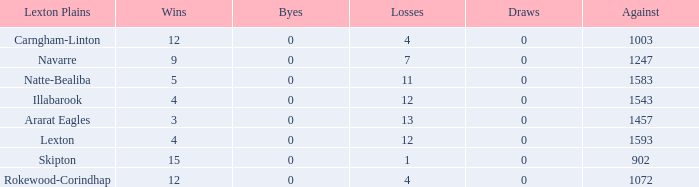What is the most wins with 0 byes? None. 